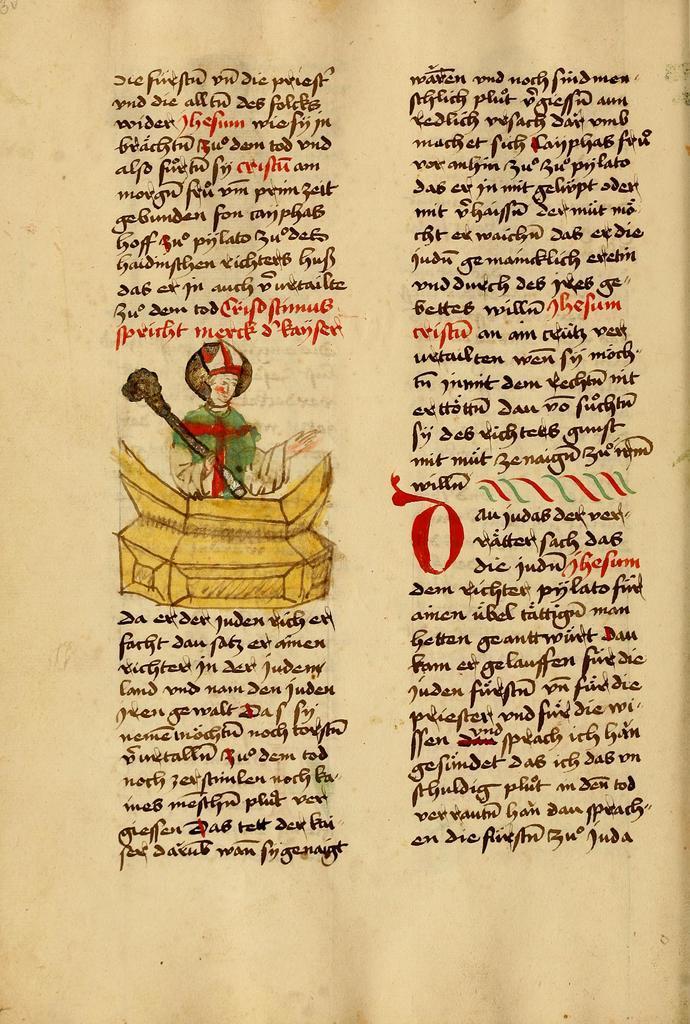Could you give a brief overview of what you see in this image? In this image we can see a paper and on the paper we can see the text and also the image of a person holding an object. 